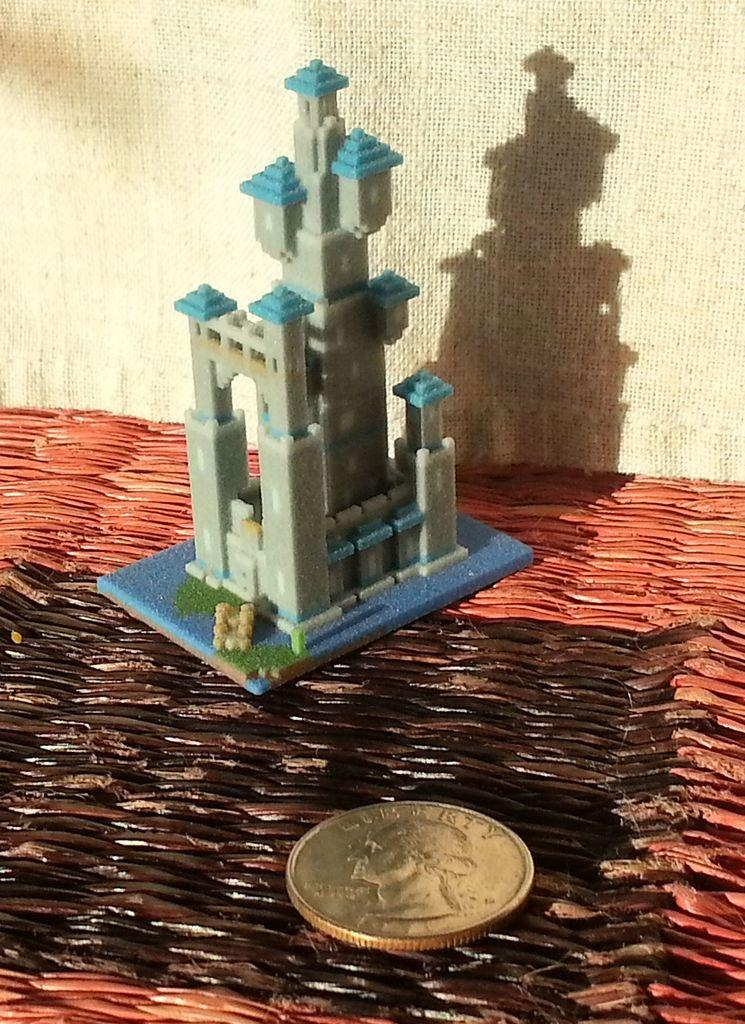What type of toy is present in the image? There is a toy building in the image. What object can be seen on the surface in the image? There is a coin on the surface in the image. What color is the background of the image? The background color is cream. How many bikes are parked next to the toy building in the image? There are no bikes present in the image. What type of wheel is attached to the toy building in the image? The toy building in the image does not have any wheels. Can you see a giraffe in the image? There is no giraffe present in the image. 